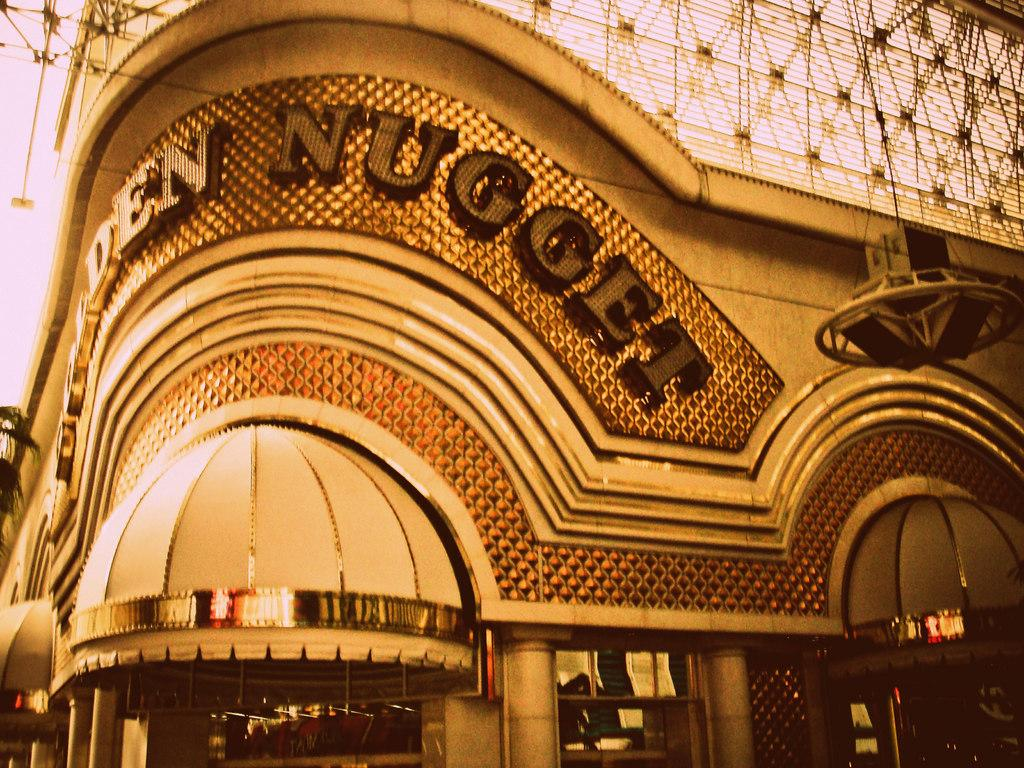What is the main subject in the center of the image? There is a building in the center of the image. What can be seen at the top of the image? There are wires at the top of the image. How many quince are hanging from the wires in the image? There are no quince present in the image; only wires can be seen at the top. 